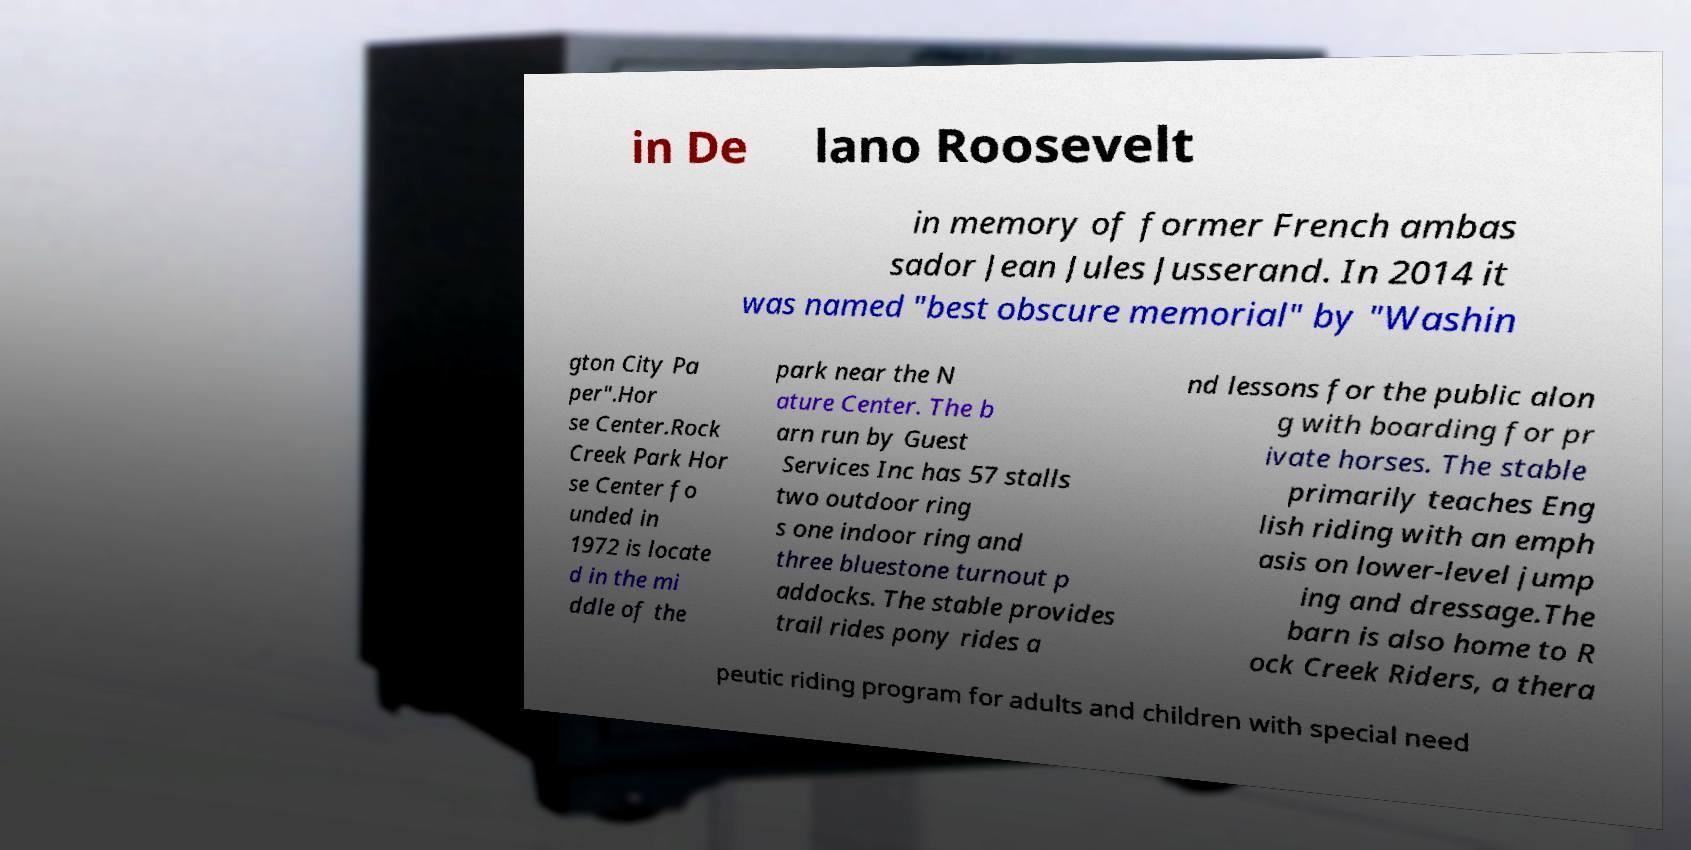Please identify and transcribe the text found in this image. in De lano Roosevelt in memory of former French ambas sador Jean Jules Jusserand. In 2014 it was named "best obscure memorial" by "Washin gton City Pa per".Hor se Center.Rock Creek Park Hor se Center fo unded in 1972 is locate d in the mi ddle of the park near the N ature Center. The b arn run by Guest Services Inc has 57 stalls two outdoor ring s one indoor ring and three bluestone turnout p addocks. The stable provides trail rides pony rides a nd lessons for the public alon g with boarding for pr ivate horses. The stable primarily teaches Eng lish riding with an emph asis on lower-level jump ing and dressage.The barn is also home to R ock Creek Riders, a thera peutic riding program for adults and children with special need 